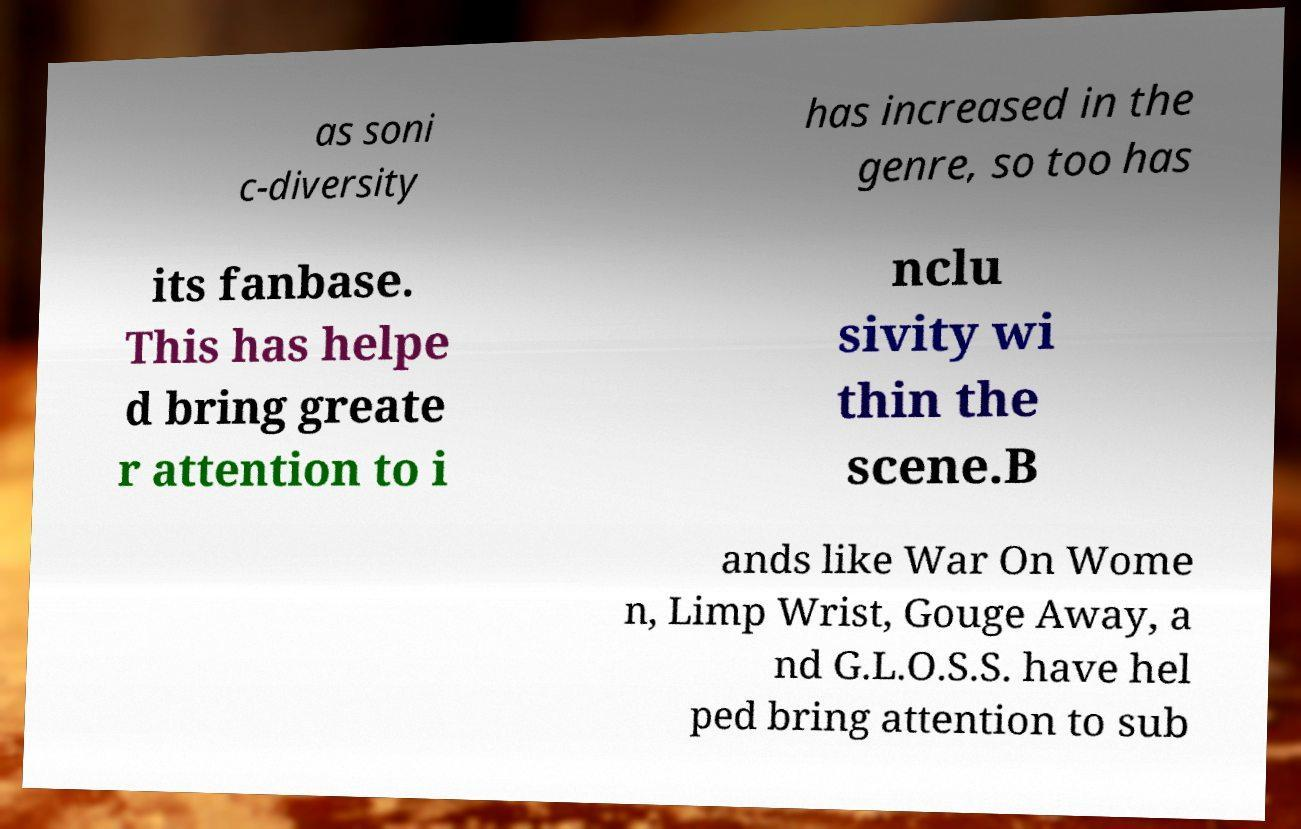There's text embedded in this image that I need extracted. Can you transcribe it verbatim? as soni c-diversity has increased in the genre, so too has its fanbase. This has helpe d bring greate r attention to i nclu sivity wi thin the scene.B ands like War On Wome n, Limp Wrist, Gouge Away, a nd G.L.O.S.S. have hel ped bring attention to sub 